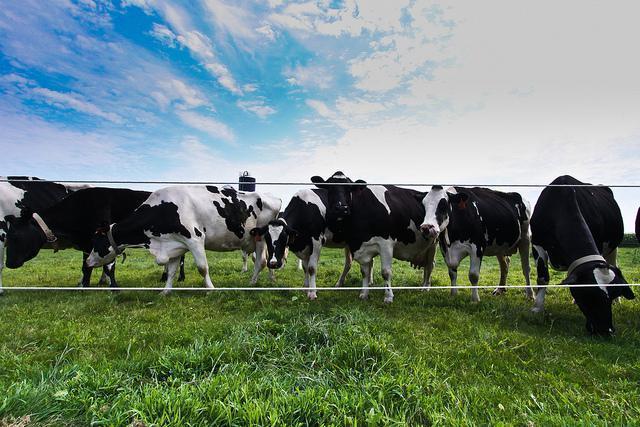What type of fence is shown here?
Answer the question by selecting the correct answer among the 4 following choices and explain your choice with a short sentence. The answer should be formatted with the following format: `Answer: choice
Rationale: rationale.`
Options: Wood stockade, none, electrified, barbed wire. Answer: electrified.
Rationale: The fence in the photo is a wire connected to an electric source and it gives the cows a shock if they make contact. this keeps them from escaping the farm. 